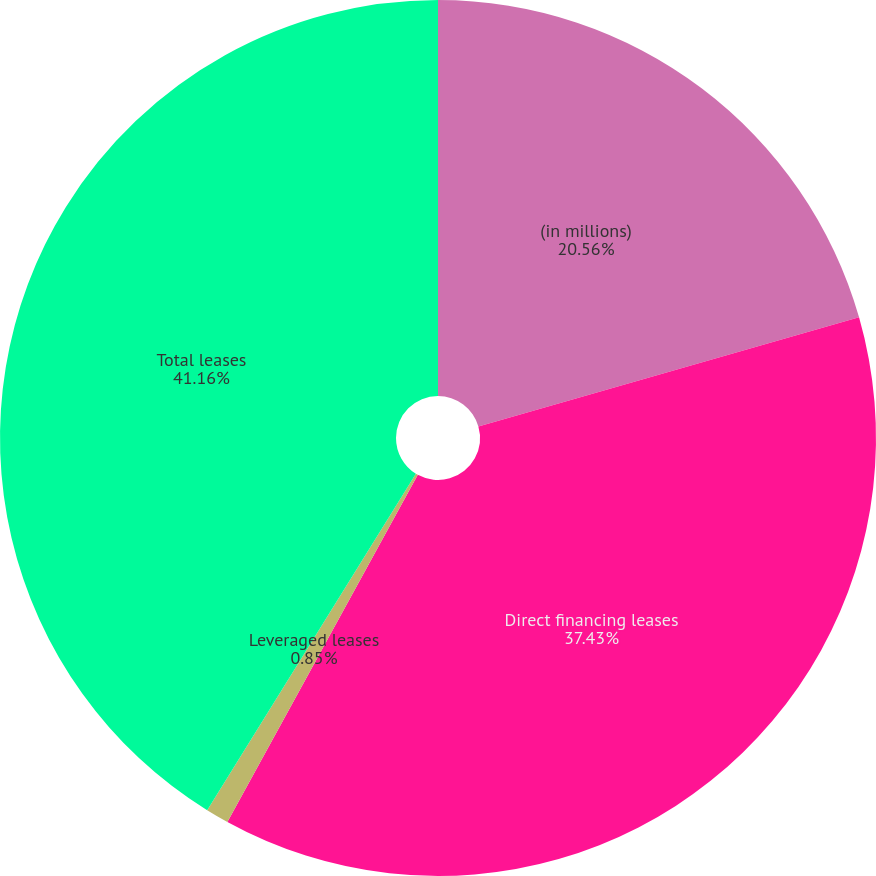Convert chart. <chart><loc_0><loc_0><loc_500><loc_500><pie_chart><fcel>(in millions)<fcel>Direct financing leases<fcel>Leveraged leases<fcel>Total leases<nl><fcel>20.56%<fcel>37.43%<fcel>0.85%<fcel>41.17%<nl></chart> 